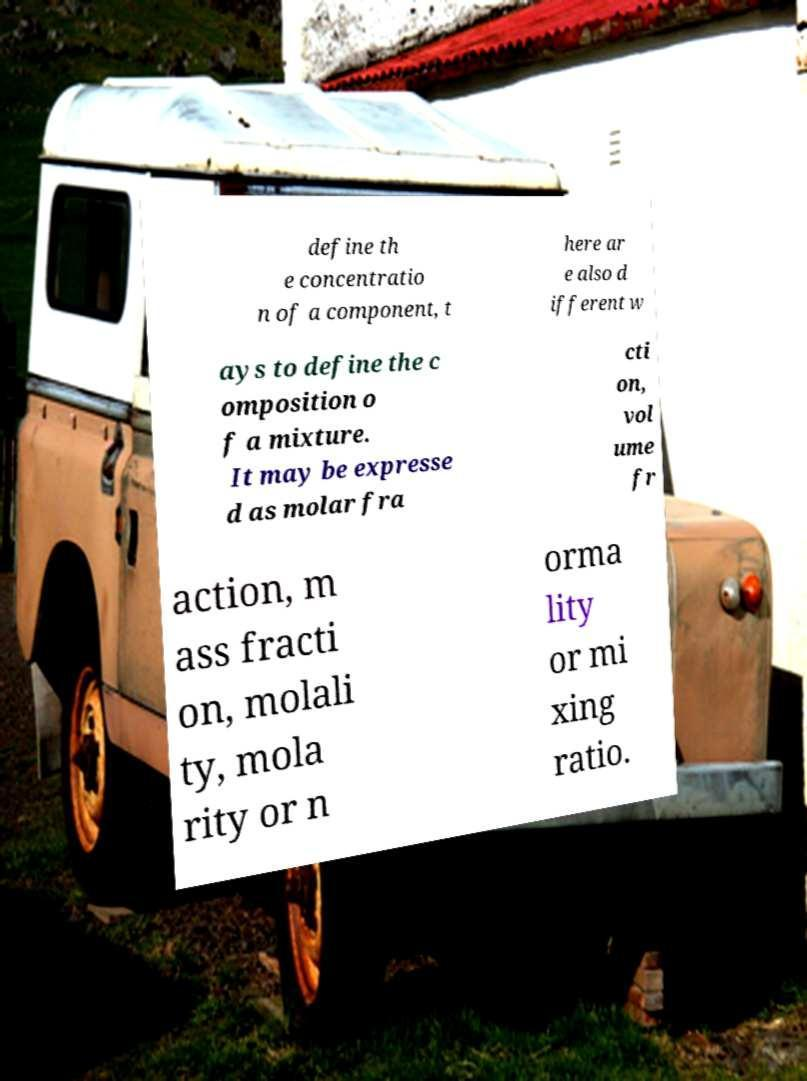There's text embedded in this image that I need extracted. Can you transcribe it verbatim? define th e concentratio n of a component, t here ar e also d ifferent w ays to define the c omposition o f a mixture. It may be expresse d as molar fra cti on, vol ume fr action, m ass fracti on, molali ty, mola rity or n orma lity or mi xing ratio. 